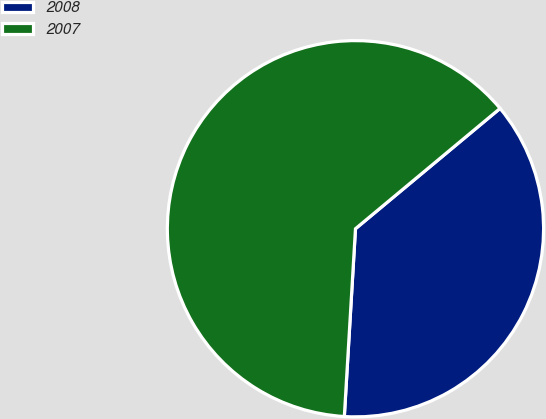Convert chart to OTSL. <chart><loc_0><loc_0><loc_500><loc_500><pie_chart><fcel>2008<fcel>2007<nl><fcel>36.99%<fcel>63.01%<nl></chart> 